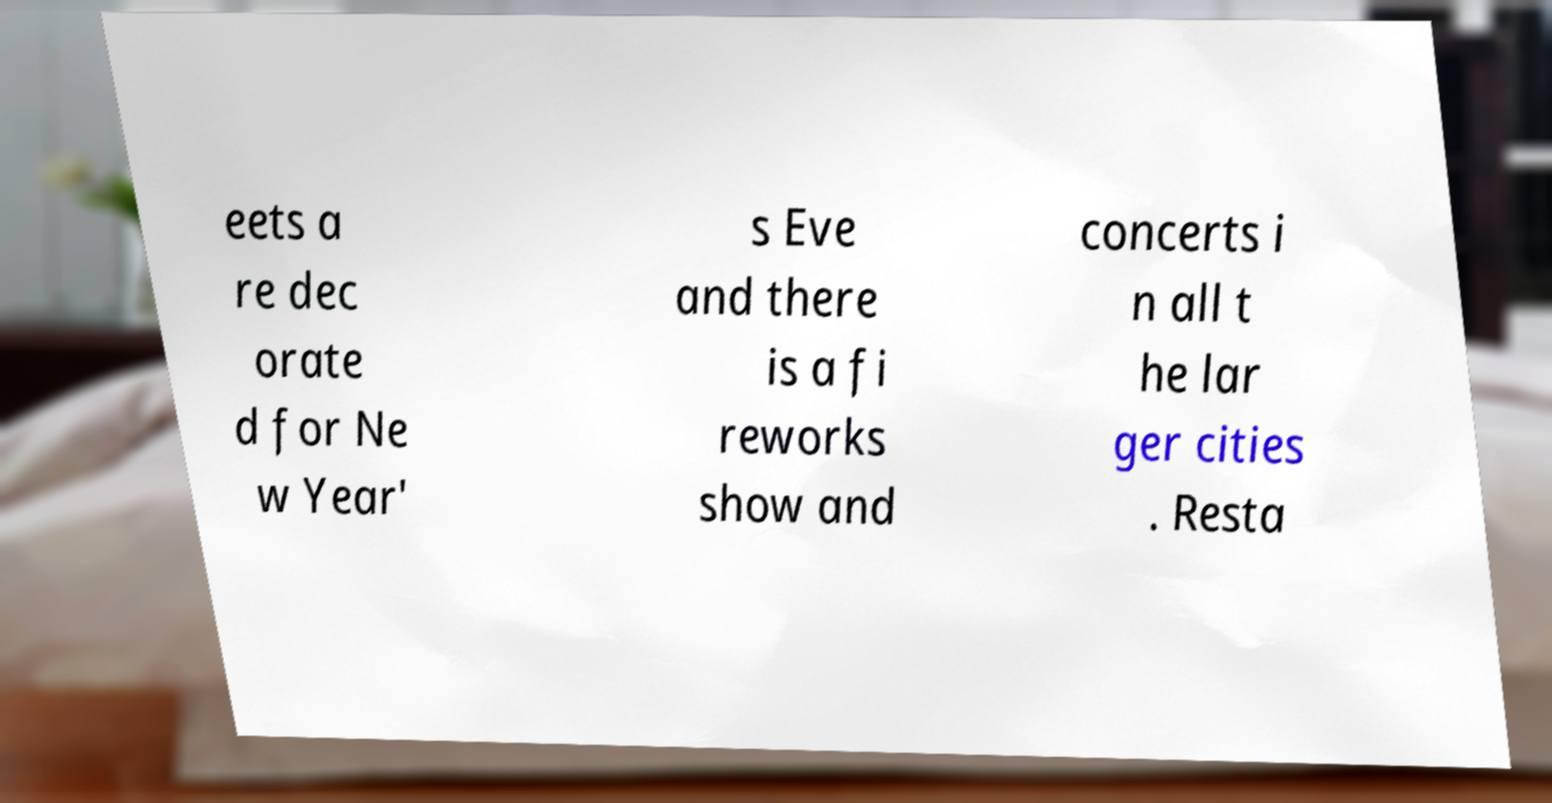Can you read and provide the text displayed in the image?This photo seems to have some interesting text. Can you extract and type it out for me? eets a re dec orate d for Ne w Year' s Eve and there is a fi reworks show and concerts i n all t he lar ger cities . Resta 